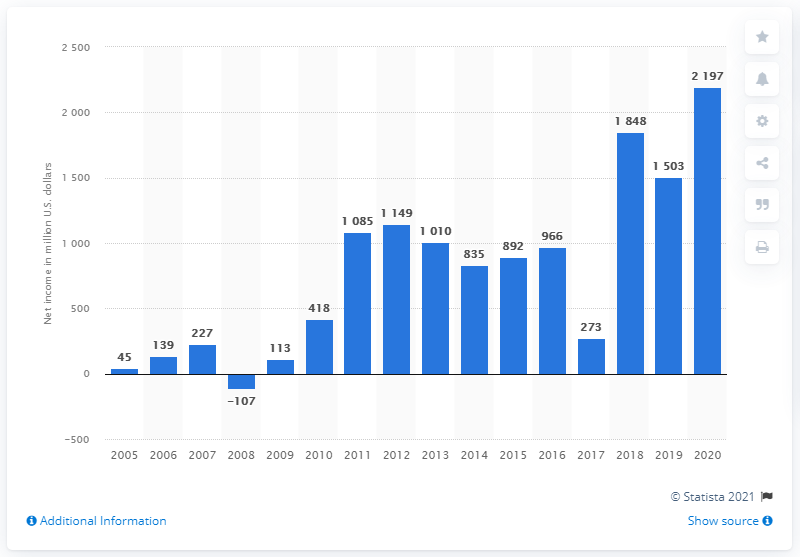Point out several critical features in this image. Activision Blizzard's net income in 2020 was approximately $2,197 million. Activision Blizzard's net income in 2019 was 1503. 